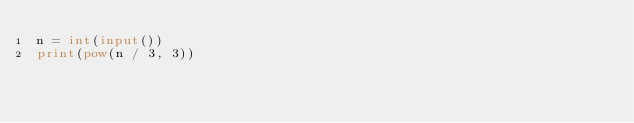<code> <loc_0><loc_0><loc_500><loc_500><_Python_>n = int(input())
print(pow(n / 3, 3))
</code> 